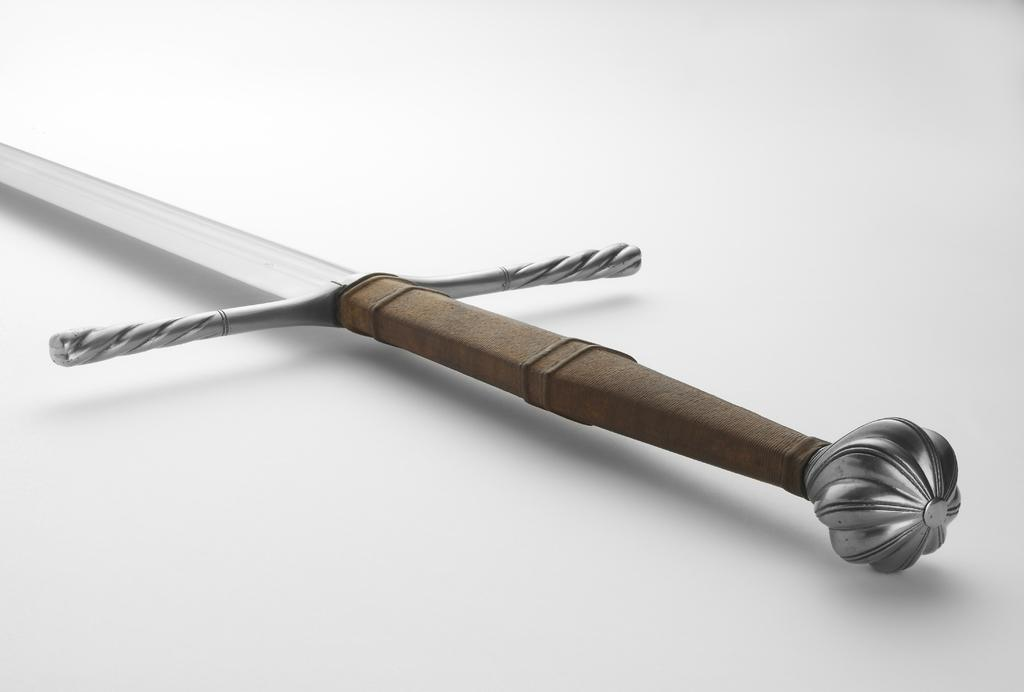What object can be seen in the image? There is a sword in the image. What is the color of the sword's handle? The sword has a brown handle. On what surface is the sword placed? The sword is placed on a white surface. How much wealth is depicted in the image? There is no indication of wealth in the image; it features a sword with a brown handle placed on a white surface. What type of noise can be heard coming from the sword in the image? There is no noise coming from the sword in the image; it is a static object. 